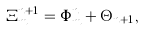Convert formula to latex. <formula><loc_0><loc_0><loc_500><loc_500>\Xi ^ { n + 1 } _ { m } = \Phi ^ { n } _ { m } + \Theta _ { n + 1 } ,</formula> 